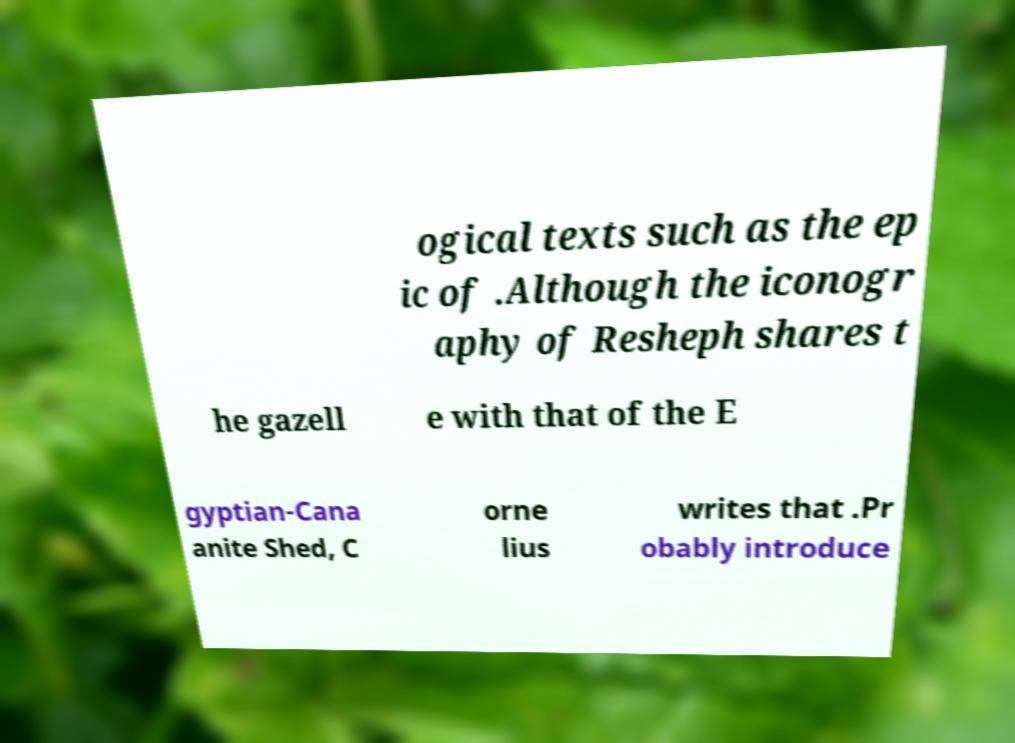Could you extract and type out the text from this image? ogical texts such as the ep ic of .Although the iconogr aphy of Resheph shares t he gazell e with that of the E gyptian-Cana anite Shed, C orne lius writes that .Pr obably introduce 